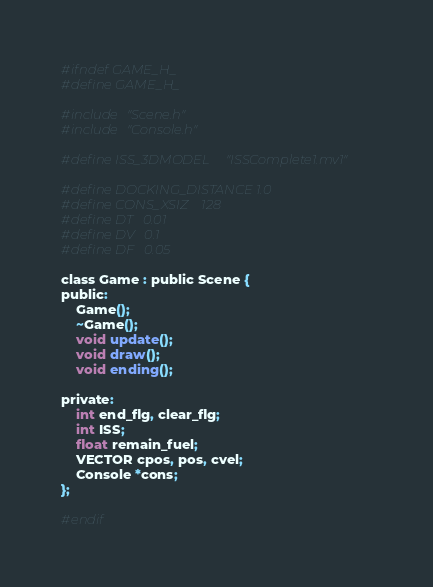Convert code to text. <code><loc_0><loc_0><loc_500><loc_500><_C_>#ifndef GAME_H_
#define GAME_H_

#include "Scene.h"
#include "Console.h"

#define ISS_3DMODEL     "ISSComplete1.mv1"

#define DOCKING_DISTANCE	1.0
#define CONS_XSIZ	128
#define DT	0.01
#define DV	0.1
#define DF	0.05

class Game : public Scene {
public:
	Game();
	~Game();
	void update();
	void draw();
	void ending();
	
private:
	int end_flg, clear_flg;
	int ISS;
	float remain_fuel;
	VECTOR cpos, pos, cvel;
	Console *cons;
};

#endif
</code> 